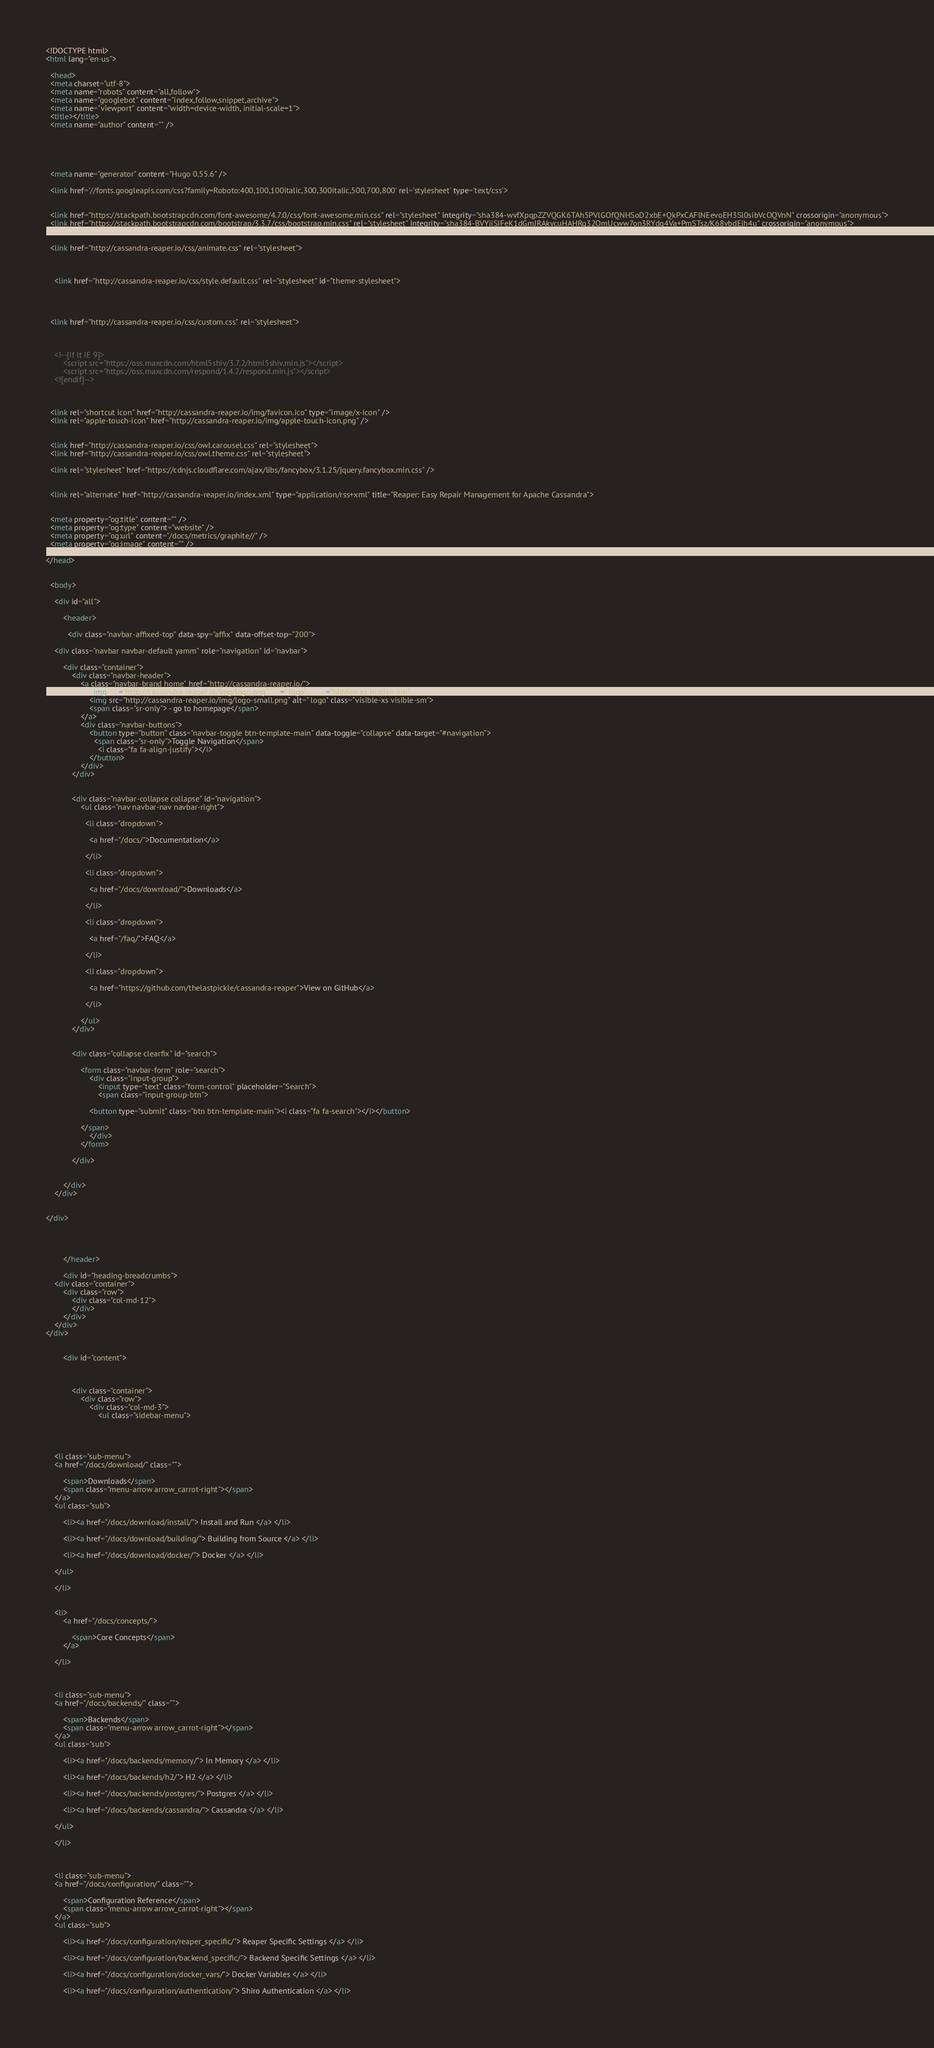<code> <loc_0><loc_0><loc_500><loc_500><_HTML_><!DOCTYPE html>
<html lang="en-us">

  <head>
  <meta charset="utf-8">
  <meta name="robots" content="all,follow">
  <meta name="googlebot" content="index,follow,snippet,archive">
  <meta name="viewport" content="width=device-width, initial-scale=1">
  <title></title>
  <meta name="author" content="" />

  

  

  <meta name="generator" content="Hugo 0.55.6" />

  <link href='//fonts.googleapis.com/css?family=Roboto:400,100,100italic,300,300italic,500,700,800' rel='stylesheet' type='text/css'>

  
  <link href="https://stackpath.bootstrapcdn.com/font-awesome/4.7.0/css/font-awesome.min.css" rel="stylesheet" integrity="sha384-wvfXpqpZZVQGK6TAh5PVlGOfQNHSoD2xbE+QkPxCAFlNEevoEH3Sl0sibVcOQVnN" crossorigin="anonymous">
  <link href="https://stackpath.bootstrapcdn.com/bootstrap/3.3.7/css/bootstrap.min.css" rel="stylesheet" integrity="sha384-BVYiiSIFeK1dGmJRAkycuHAHRg32OmUcww7on3RYdg4Va+PmSTsz/K68vbdEjh4u" crossorigin="anonymous">

  
  <link href="http://cassandra-reaper.io/css/animate.css" rel="stylesheet">

  
  
    <link href="http://cassandra-reaper.io/css/style.default.css" rel="stylesheet" id="theme-stylesheet">
  


  
  <link href="http://cassandra-reaper.io/css/custom.css" rel="stylesheet">

  
  
    <!--[if lt IE 9]>
        <script src="https://oss.maxcdn.com/html5shiv/3.7.2/html5shiv.min.js"></script>
        <script src="https://oss.maxcdn.com/respond/1.4.2/respond.min.js"></script>
    <![endif]-->
  

  
  <link rel="shortcut icon" href="http://cassandra-reaper.io/img/favicon.ico" type="image/x-icon" />
  <link rel="apple-touch-icon" href="http://cassandra-reaper.io/img/apple-touch-icon.png" />
  

  <link href="http://cassandra-reaper.io/css/owl.carousel.css" rel="stylesheet">
  <link href="http://cassandra-reaper.io/css/owl.theme.css" rel="stylesheet">

  <link rel="stylesheet" href="https://cdnjs.cloudflare.com/ajax/libs/fancybox/3.1.25/jquery.fancybox.min.css" />


  <link rel="alternate" href="http://cassandra-reaper.io/index.xml" type="application/rss+xml" title="Reaper: Easy Repair Management for Apache Cassandra">

  
  <meta property="og:title" content="" />
  <meta property="og:type" content="website" />
  <meta property="og:url" content="/docs/metrics/graphite//" />
  <meta property="og:image" content="" />

</head>


  <body>

    <div id="all">

        <header>

          <div class="navbar-affixed-top" data-spy="affix" data-offset-top="200">

    <div class="navbar navbar-default yamm" role="navigation" id="navbar">

        <div class="container">
            <div class="navbar-header">
                <a class="navbar-brand home" href="http://cassandra-reaper.io/">
                    <img src="http://cassandra-reaper.io/img/logo.png" alt=" logo" class="hidden-xs hidden-sm">
                    <img src="http://cassandra-reaper.io/img/logo-small.png" alt=" logo" class="visible-xs visible-sm">
                    <span class="sr-only"> - go to homepage</span>
                </a>
                <div class="navbar-buttons">
                    <button type="button" class="navbar-toggle btn-template-main" data-toggle="collapse" data-target="#navigation">
                      <span class="sr-only">Toggle Navigation</span>
                        <i class="fa fa-align-justify"></i>
                    </button>
                </div>
            </div>
            

            <div class="navbar-collapse collapse" id="navigation">
                <ul class="nav navbar-nav navbar-right">
                  
                  <li class="dropdown">
                    
                    <a href="/docs/">Documentation</a>
                    
                  </li>
                  
                  <li class="dropdown">
                    
                    <a href="/docs/download/">Downloads</a>
                    
                  </li>
                  
                  <li class="dropdown">
                    
                    <a href="/faq/">FAQ</a>
                    
                  </li>
                  
                  <li class="dropdown">
                    
                    <a href="https://github.com/thelastpickle/cassandra-reaper">View on GitHub</a>
                    
                  </li>
                  
                </ul>
            </div>
            

            <div class="collapse clearfix" id="search">

                <form class="navbar-form" role="search">
                    <div class="input-group">
                        <input type="text" class="form-control" placeholder="Search">
                        <span class="input-group-btn">

                    <button type="submit" class="btn btn-template-main"><i class="fa fa-search"></i></button>

                </span>
                    </div>
                </form>

            </div>
            

        </div>
    </div>
    

</div>




        </header>

        <div id="heading-breadcrumbs">
    <div class="container">
        <div class="row">
            <div class="col-md-12">
            </div>
        </div>
    </div>
</div>


        <div id="content">

            

            <div class="container">
                <div class="row">
                    <div class="col-md-3">
                        <ul class="sidebar-menu">
    
    
    

    <li class="sub-menu">
    <a href="/docs/download/" class="">
        
        <span>Downloads</span>
        <span class="menu-arrow arrow_carrot-right"></span>
    </a>
    <ul class="sub">
        
        <li><a href="/docs/download/install/"> Install and Run </a> </li>
        
        <li><a href="/docs/download/building/"> Building from Source </a> </li>
        
        <li><a href="/docs/download/docker/"> Docker </a> </li>
        
    </ul>
    
    </li>
    
    
    <li>
        <a href="/docs/concepts/">
            
            <span>Core Concepts</span>
        </a>
        
    </li>
    
    

    <li class="sub-menu">
    <a href="/docs/backends/" class="">
        
        <span>Backends</span>
        <span class="menu-arrow arrow_carrot-right"></span>
    </a>
    <ul class="sub">
        
        <li><a href="/docs/backends/memory/"> In Memory </a> </li>
        
        <li><a href="/docs/backends/h2/"> H2 </a> </li>
        
        <li><a href="/docs/backends/postgres/"> Postgres </a> </li>
        
        <li><a href="/docs/backends/cassandra/"> Cassandra </a> </li>
        
    </ul>
    
    </li>
    
    

    <li class="sub-menu">
    <a href="/docs/configuration/" class="">
        
        <span>Configuration Reference</span>
        <span class="menu-arrow arrow_carrot-right"></span>
    </a>
    <ul class="sub">
        
        <li><a href="/docs/configuration/reaper_specific/"> Reaper Specific Settings </a> </li>
        
        <li><a href="/docs/configuration/backend_specific/"> Backend Specific Settings </a> </li>
        
        <li><a href="/docs/configuration/docker_vars/"> Docker Variables </a> </li>
        
        <li><a href="/docs/configuration/authentication/"> Shiro Authentication </a> </li>
        </code> 